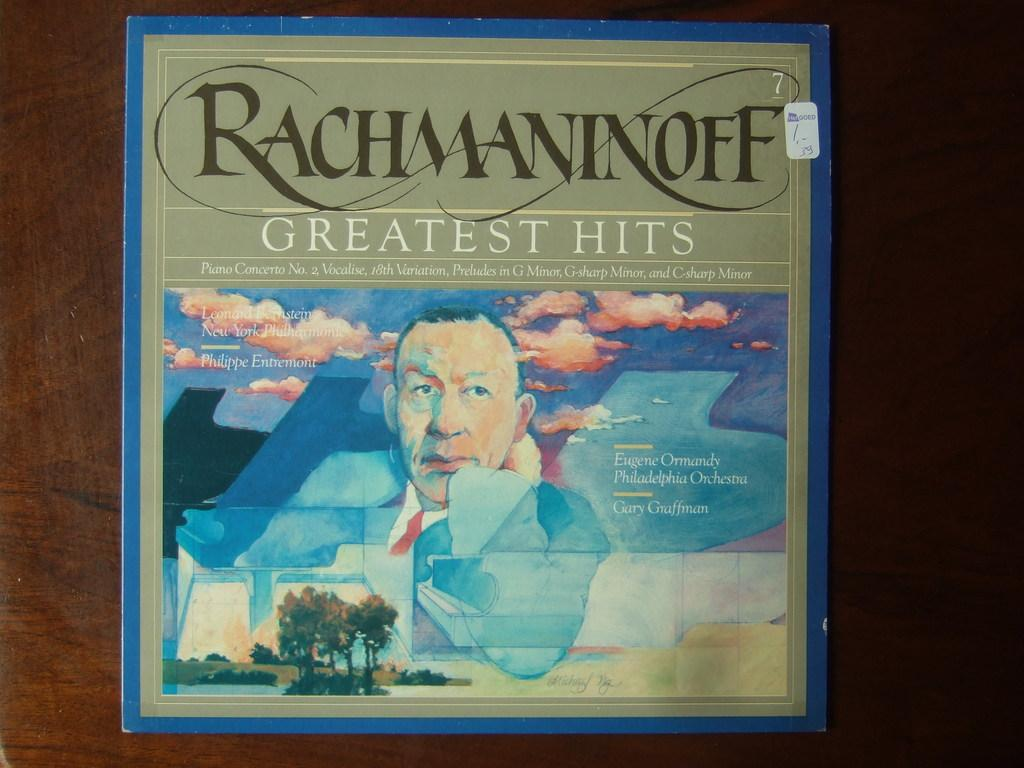<image>
Provide a brief description of the given image. A vinyl album of Rachmaninoff's greatest hits as performed by the Philadelphia Orchestra. 